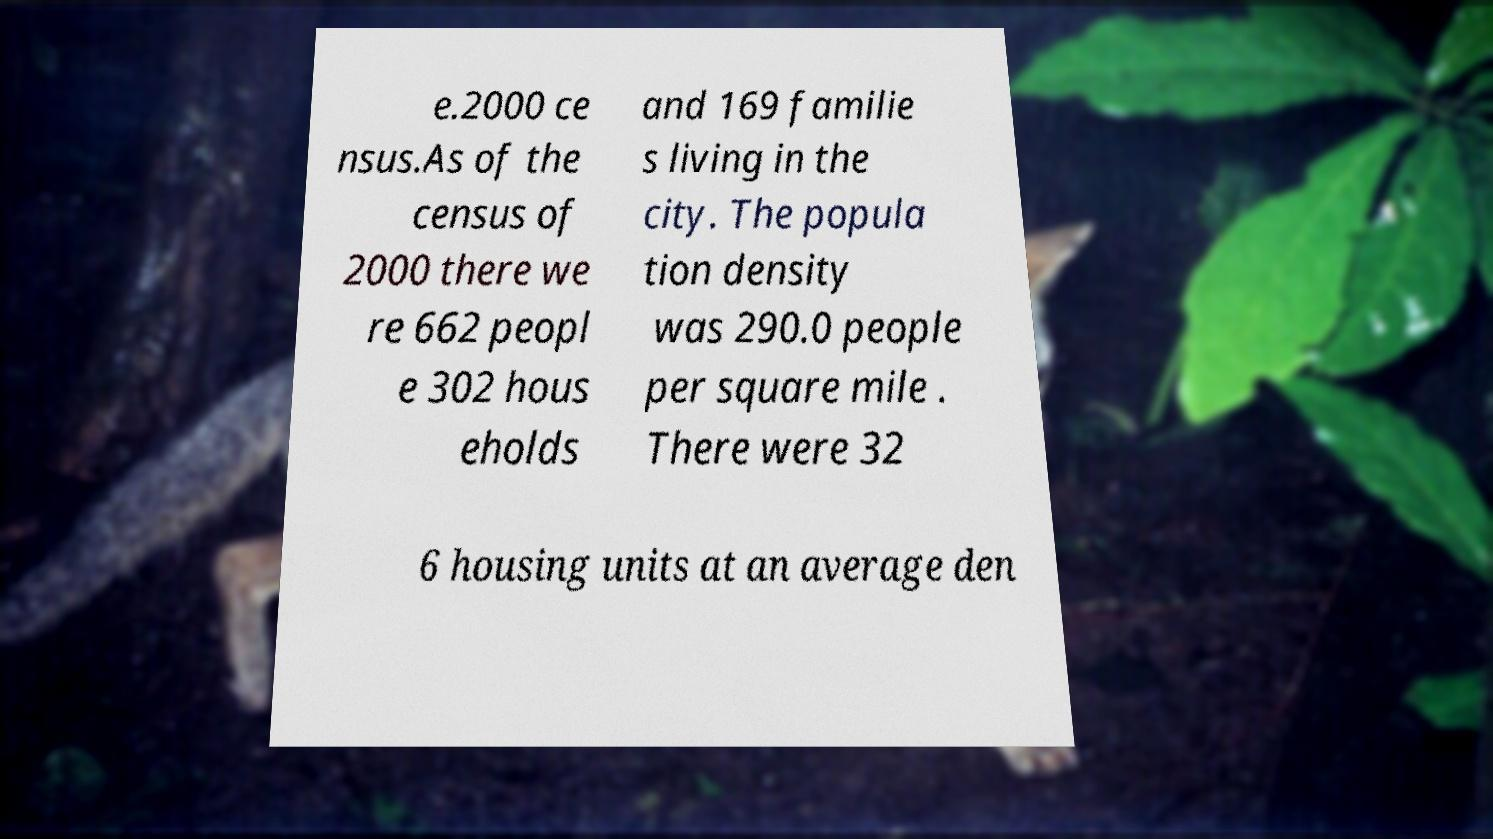Can you read and provide the text displayed in the image?This photo seems to have some interesting text. Can you extract and type it out for me? e.2000 ce nsus.As of the census of 2000 there we re 662 peopl e 302 hous eholds and 169 familie s living in the city. The popula tion density was 290.0 people per square mile . There were 32 6 housing units at an average den 